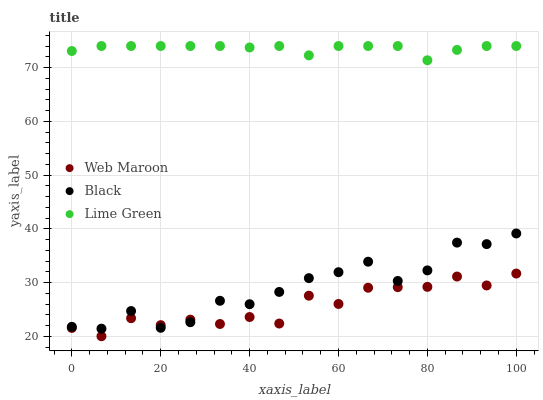Does Web Maroon have the minimum area under the curve?
Answer yes or no. Yes. Does Lime Green have the maximum area under the curve?
Answer yes or no. Yes. Does Lime Green have the minimum area under the curve?
Answer yes or no. No. Does Web Maroon have the maximum area under the curve?
Answer yes or no. No. Is Lime Green the smoothest?
Answer yes or no. Yes. Is Black the roughest?
Answer yes or no. Yes. Is Web Maroon the smoothest?
Answer yes or no. No. Is Web Maroon the roughest?
Answer yes or no. No. Does Web Maroon have the lowest value?
Answer yes or no. Yes. Does Lime Green have the lowest value?
Answer yes or no. No. Does Lime Green have the highest value?
Answer yes or no. Yes. Does Web Maroon have the highest value?
Answer yes or no. No. Is Black less than Lime Green?
Answer yes or no. Yes. Is Lime Green greater than Web Maroon?
Answer yes or no. Yes. Does Black intersect Web Maroon?
Answer yes or no. Yes. Is Black less than Web Maroon?
Answer yes or no. No. Is Black greater than Web Maroon?
Answer yes or no. No. Does Black intersect Lime Green?
Answer yes or no. No. 